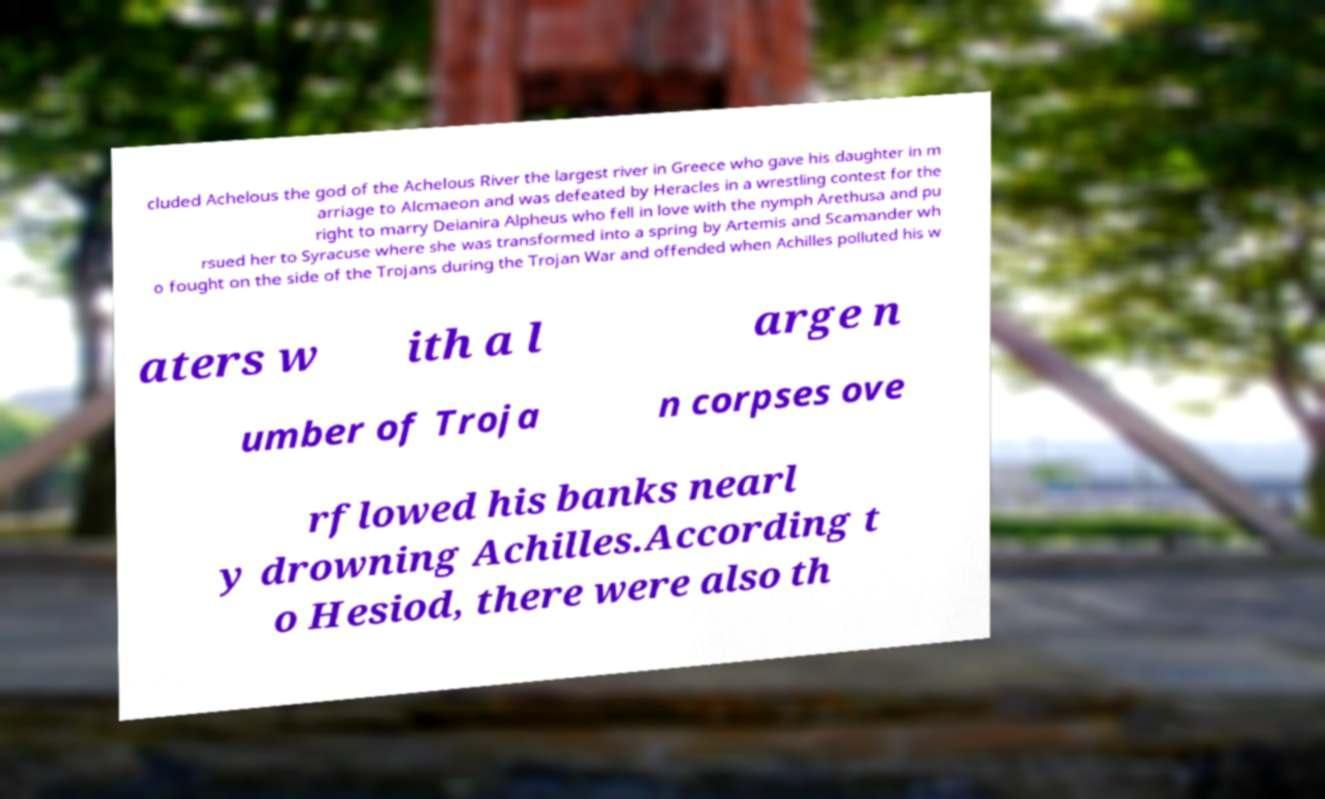Please read and relay the text visible in this image. What does it say? cluded Achelous the god of the Achelous River the largest river in Greece who gave his daughter in m arriage to Alcmaeon and was defeated by Heracles in a wrestling contest for the right to marry Deianira Alpheus who fell in love with the nymph Arethusa and pu rsued her to Syracuse where she was transformed into a spring by Artemis and Scamander wh o fought on the side of the Trojans during the Trojan War and offended when Achilles polluted his w aters w ith a l arge n umber of Troja n corpses ove rflowed his banks nearl y drowning Achilles.According t o Hesiod, there were also th 